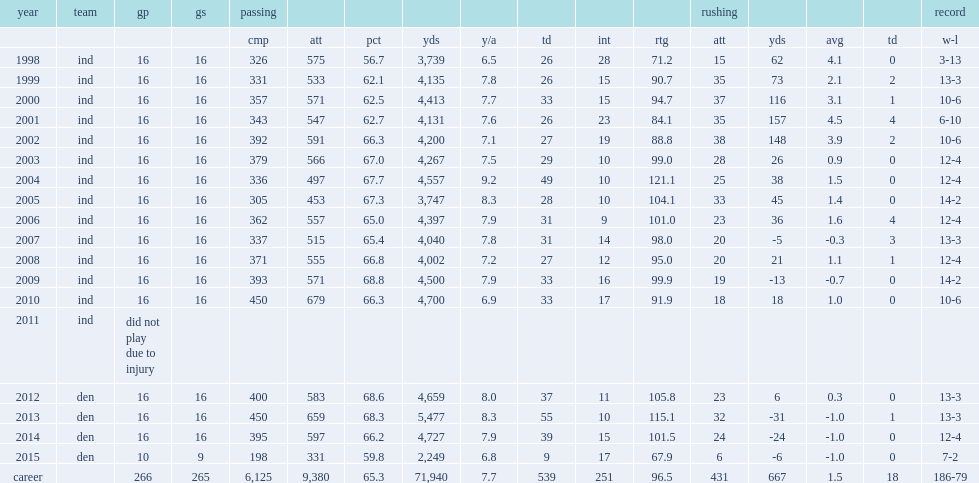How many passing yards did peyton manning get in 2013? 5477.0. Give me the full table as a dictionary. {'header': ['year', 'team', 'gp', 'gs', 'passing', '', '', '', '', '', '', '', 'rushing', '', '', '', 'record'], 'rows': [['', '', '', '', 'cmp', 'att', 'pct', 'yds', 'y/a', 'td', 'int', 'rtg', 'att', 'yds', 'avg', 'td', 'w-l'], ['1998', 'ind', '16', '16', '326', '575', '56.7', '3,739', '6.5', '26', '28', '71.2', '15', '62', '4.1', '0', '3-13'], ['1999', 'ind', '16', '16', '331', '533', '62.1', '4,135', '7.8', '26', '15', '90.7', '35', '73', '2.1', '2', '13-3'], ['2000', 'ind', '16', '16', '357', '571', '62.5', '4,413', '7.7', '33', '15', '94.7', '37', '116', '3.1', '1', '10-6'], ['2001', 'ind', '16', '16', '343', '547', '62.7', '4,131', '7.6', '26', '23', '84.1', '35', '157', '4.5', '4', '6-10'], ['2002', 'ind', '16', '16', '392', '591', '66.3', '4,200', '7.1', '27', '19', '88.8', '38', '148', '3.9', '2', '10-6'], ['2003', 'ind', '16', '16', '379', '566', '67.0', '4,267', '7.5', '29', '10', '99.0', '28', '26', '0.9', '0', '12-4'], ['2004', 'ind', '16', '16', '336', '497', '67.7', '4,557', '9.2', '49', '10', '121.1', '25', '38', '1.5', '0', '12-4'], ['2005', 'ind', '16', '16', '305', '453', '67.3', '3,747', '8.3', '28', '10', '104.1', '33', '45', '1.4', '0', '14-2'], ['2006', 'ind', '16', '16', '362', '557', '65.0', '4,397', '7.9', '31', '9', '101.0', '23', '36', '1.6', '4', '12-4'], ['2007', 'ind', '16', '16', '337', '515', '65.4', '4,040', '7.8', '31', '14', '98.0', '20', '-5', '-0.3', '3', '13-3'], ['2008', 'ind', '16', '16', '371', '555', '66.8', '4,002', '7.2', '27', '12', '95.0', '20', '21', '1.1', '1', '12-4'], ['2009', 'ind', '16', '16', '393', '571', '68.8', '4,500', '7.9', '33', '16', '99.9', '19', '-13', '-0.7', '0', '14-2'], ['2010', 'ind', '16', '16', '450', '679', '66.3', '4,700', '6.9', '33', '17', '91.9', '18', '18', '1.0', '0', '10-6'], ['2011', 'ind', 'did not play due to injury', '', '', '', '', '', '', '', '', '', '', '', '', '', ''], ['2012', 'den', '16', '16', '400', '583', '68.6', '4,659', '8.0', '37', '11', '105.8', '23', '6', '0.3', '0', '13-3'], ['2013', 'den', '16', '16', '450', '659', '68.3', '5,477', '8.3', '55', '10', '115.1', '32', '-31', '-1.0', '1', '13-3'], ['2014', 'den', '16', '16', '395', '597', '66.2', '4,727', '7.9', '39', '15', '101.5', '24', '-24', '-1.0', '0', '12-4'], ['2015', 'den', '10', '9', '198', '331', '59.8', '2,249', '6.8', '9', '17', '67.9', '6', '-6', '-1.0', '0', '7-2'], ['career', '', '266', '265', '6,125', '9,380', '65.3', '71,940', '7.7', '539', '251', '96.5', '431', '667', '1.5', '18', '186-79']]} 